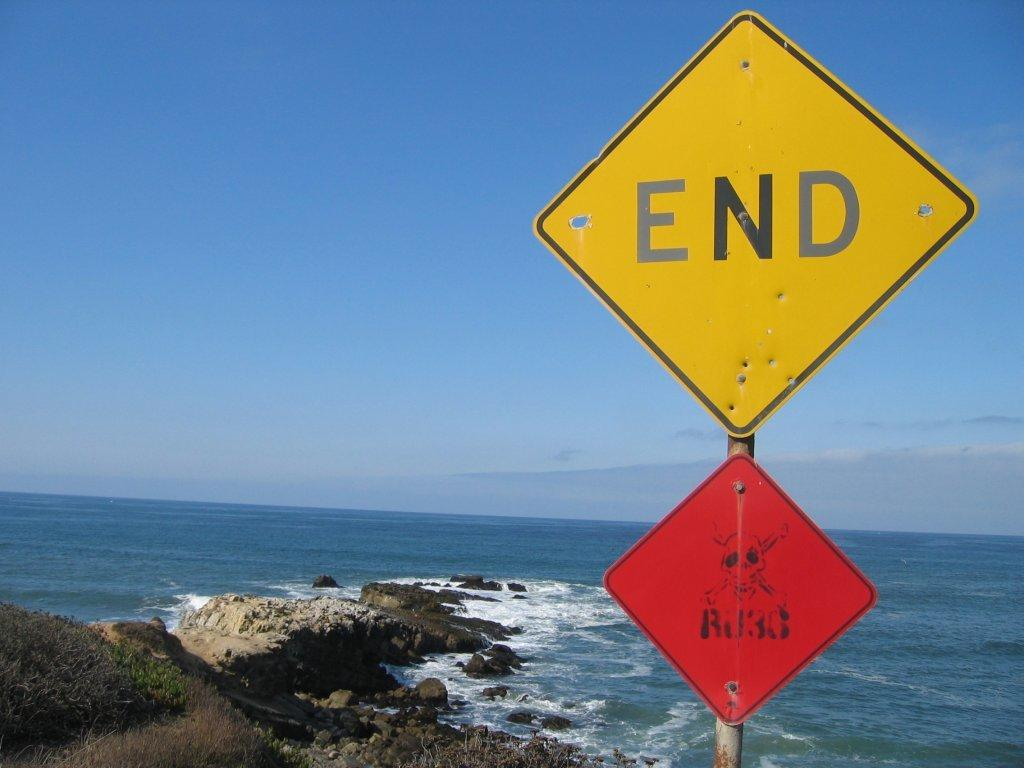Provide a one-sentence caption for the provided image. A picture of a beach with a sign that says End. 